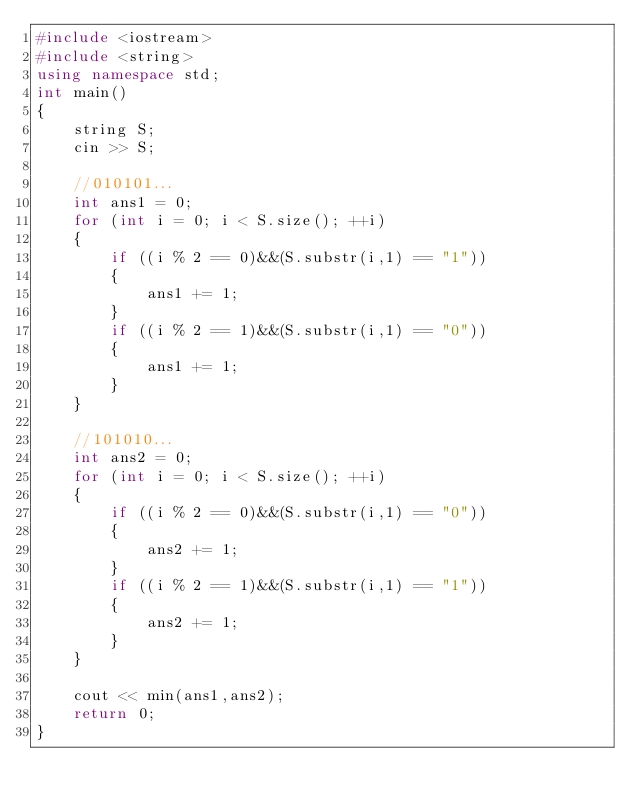Convert code to text. <code><loc_0><loc_0><loc_500><loc_500><_C++_>#include <iostream>
#include <string>
using namespace std;
int main()
{
	string S;
	cin >> S;

	//010101...
	int ans1 = 0;
	for (int i = 0; i < S.size(); ++i)
	{
		if ((i % 2 == 0)&&(S.substr(i,1) == "1"))
		{
			ans1 += 1;
		}
		if ((i % 2 == 1)&&(S.substr(i,1) == "0"))
		{
			ans1 += 1;
		}
	}

	//101010...
	int ans2 = 0;
	for (int i = 0; i < S.size(); ++i)
	{
		if ((i % 2 == 0)&&(S.substr(i,1) == "0"))
		{
			ans2 += 1;
		}
		if ((i % 2 == 1)&&(S.substr(i,1) == "1"))
		{
			ans2 += 1;
		}
	}

	cout << min(ans1,ans2);
	return 0;
}</code> 